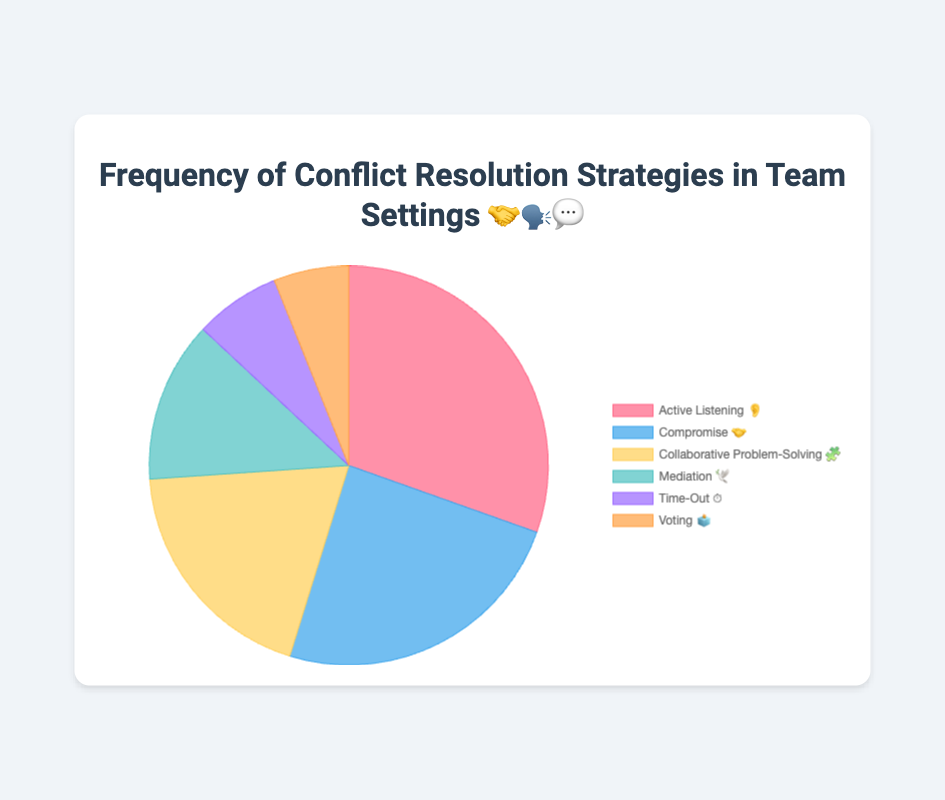which conflict resolution strategy is used most frequently? The figure shows that "Active Listening 👂" has the highest segment in the pie chart, indicating it is the most frequently used strategy.
Answer: Active Listening 👂 which two strategies have the lowest usage frequencies? The smallest segments in the pie chart are "Voting 🗳️" and "Time-Out ⏱️," showing that these two have the lowest frequencies.
Answer: Voting 🗳️ and Time-Out ⏱️ what is the total frequency of the top three strategies combined? The frequencies of the top three strategies, "Active Listening 👂" (35), "Compromise 🤝" (28), and "Collaborative Problem-Solving 🧩" (22), sum up to 35 + 28 + 22 = 85.
Answer: 85 how much more frequent is "Active Listening 👂" compared to "Mediation 🕊️"? "Active Listening 👂" has a frequency of 35, while "Mediation 🕊️" has 15. The difference is 35 - 15 = 20.
Answer: 20 which strategy has a frequency twice that of "Voting 🗳️"? "Voting 🗳️" has a frequency of 7. Doubling this gives 2 * 7 = 14, and the closest frequency is "Mediation 🕊️" with 15.
Answer: Mediation 🕊️ what is the average frequency of all the strategies? The total frequency is 35 + 28 + 22 + 15 + 8 + 7 = 115. There are 6 strategies, so the average is 115 / 6 ≈ 19.17.
Answer: 19.17 which strategy has a frequency closest to the average frequency? The average frequency is approximately 19.17. "Collaborative Problem-Solving 🧩" with a frequency of 22 is the closest to this value.
Answer: Collaborative Problem-Solving 🧩 